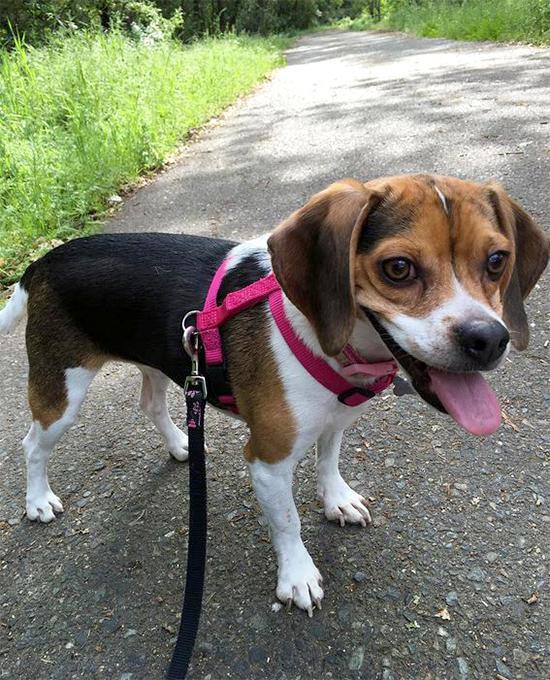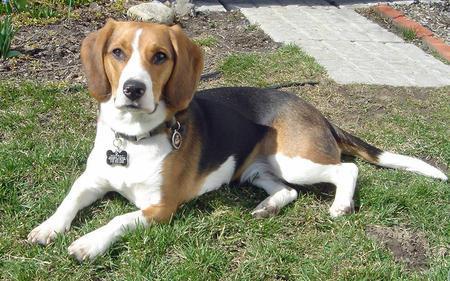The first image is the image on the left, the second image is the image on the right. For the images displayed, is the sentence "At least one dog is one a leash in one of the images." factually correct? Answer yes or no. Yes. The first image is the image on the left, the second image is the image on the right. For the images displayed, is the sentence "At least one of the dogs is inside." factually correct? Answer yes or no. No. 